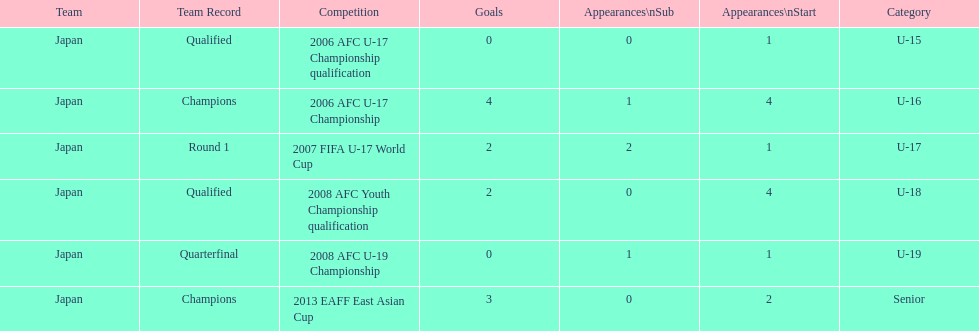How many total goals were scored? 11. 